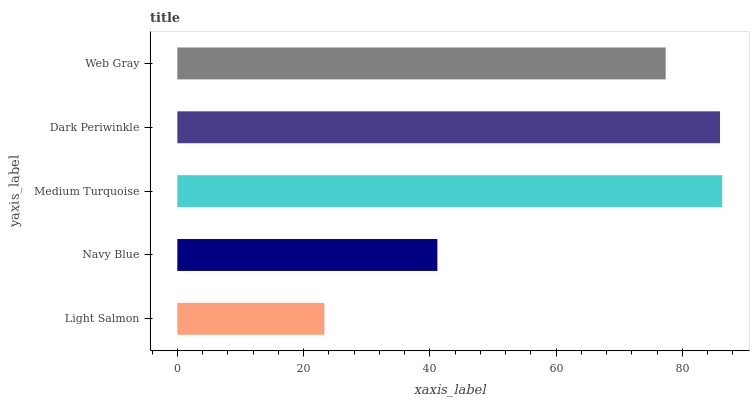Is Light Salmon the minimum?
Answer yes or no. Yes. Is Medium Turquoise the maximum?
Answer yes or no. Yes. Is Navy Blue the minimum?
Answer yes or no. No. Is Navy Blue the maximum?
Answer yes or no. No. Is Navy Blue greater than Light Salmon?
Answer yes or no. Yes. Is Light Salmon less than Navy Blue?
Answer yes or no. Yes. Is Light Salmon greater than Navy Blue?
Answer yes or no. No. Is Navy Blue less than Light Salmon?
Answer yes or no. No. Is Web Gray the high median?
Answer yes or no. Yes. Is Web Gray the low median?
Answer yes or no. Yes. Is Light Salmon the high median?
Answer yes or no. No. Is Navy Blue the low median?
Answer yes or no. No. 